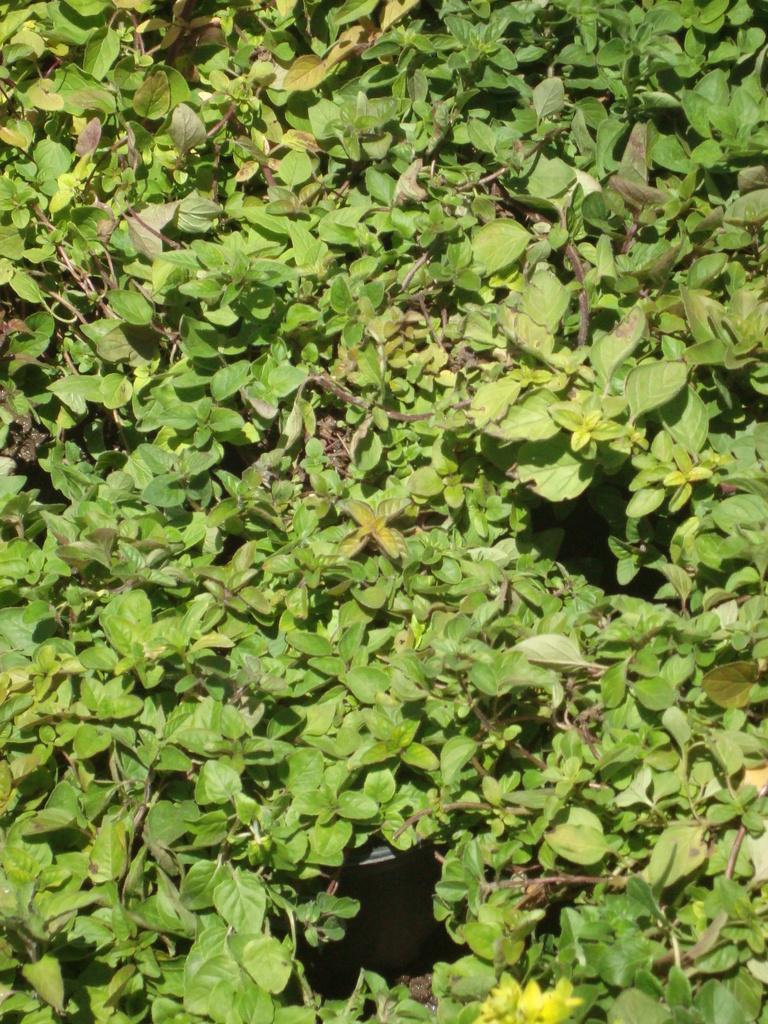Describe this image in one or two sentences. In this image we can see leaves and stems. 